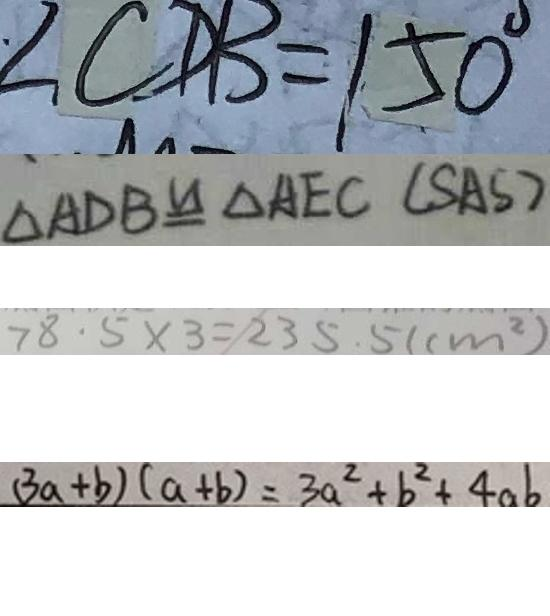Convert formula to latex. <formula><loc_0><loc_0><loc_500><loc_500>\angle C D B = 1 5 0 ^ { \circ } 
 \Delta A D B \cong \Delta A E C ( S A S ) 
 7 8 . 5 \times 3 = 2 3 5 . 5 ( c m ^ { 2 } ) 
 ( 3 a + b ) ( a + b ) = 3 a ^ { 2 } + b ^ { 2 } + 4 a b</formula> 